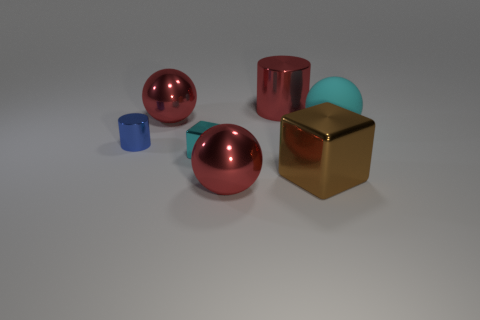Are there any other things that have the same material as the large cyan ball?
Keep it short and to the point. No. What number of other objects are the same shape as the big rubber thing?
Your answer should be compact. 2. There is a big object that is both in front of the cyan rubber ball and left of the large shiny cube; what is its shape?
Provide a short and direct response. Sphere. There is a cylinder on the left side of the big red sphere on the right side of the large shiny sphere behind the tiny blue shiny object; what color is it?
Give a very brief answer. Blue. Is the number of cyan things that are on the right side of the large metal block greater than the number of large cyan things that are right of the large cyan rubber sphere?
Offer a terse response. Yes. What number of other objects are there of the same size as the blue cylinder?
Your answer should be very brief. 1. There is a shiny thing that is the same color as the rubber thing; what size is it?
Your answer should be compact. Small. What material is the block that is to the right of the shiny cylinder behind the big cyan ball?
Keep it short and to the point. Metal. There is a tiny cyan metallic thing; are there any blue objects to the right of it?
Offer a very short reply. No. Are there more red cylinders in front of the big shiny cube than large cyan objects?
Offer a very short reply. No. 